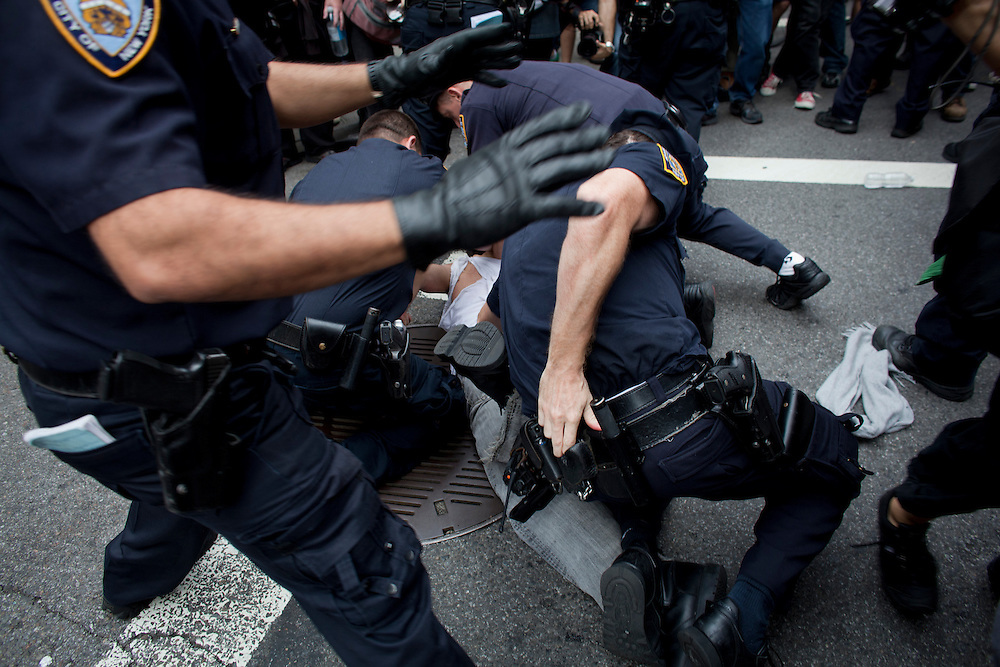Describe a possible short-scenario leading up to this moment. A small protest in the heart of the city escalated when a provocative statement by a protester drew a strong response from the assembled crowd. Tensions rose, and soon the police were called in to maintain order. Amidst the chaos, one particularly vocal individual was singled out and subdued to prevent further unrest, leading to the scene depicted in this image. Describe a detailed long-scenario leading up to this moment. Over the past year, the city had become a hotspot for activism, with citizens rallying against various socio-political issues. On this particular day, a massive protest was organized to confront a controversial new law. Hundreds of people gathered, chanting and holding signs, their passion filling the streets. The atmosphere was charged but peaceful until a small counter-protest group arrived. Verbal confrontations quickly turned physical as tensions boiled over. The police, prepared for potential conflict, moved in to separate the groups and maintain peace. Amid the chaos, an individual known for their outspoken critiques of the government's policies became the focal point of the unrest. The police, aiming to prevent an escalation, targeted this individual for detention. Despite their non-violent stance, they were subdued with force to make an example and deter further aggression. This sequence of events led to the moment captured in the image, a snapshot of a city caught in the throes of civil discontent and authoritative response. 